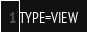<code> <loc_0><loc_0><loc_500><loc_500><_VisualBasic_>TYPE=VIEW</code> 